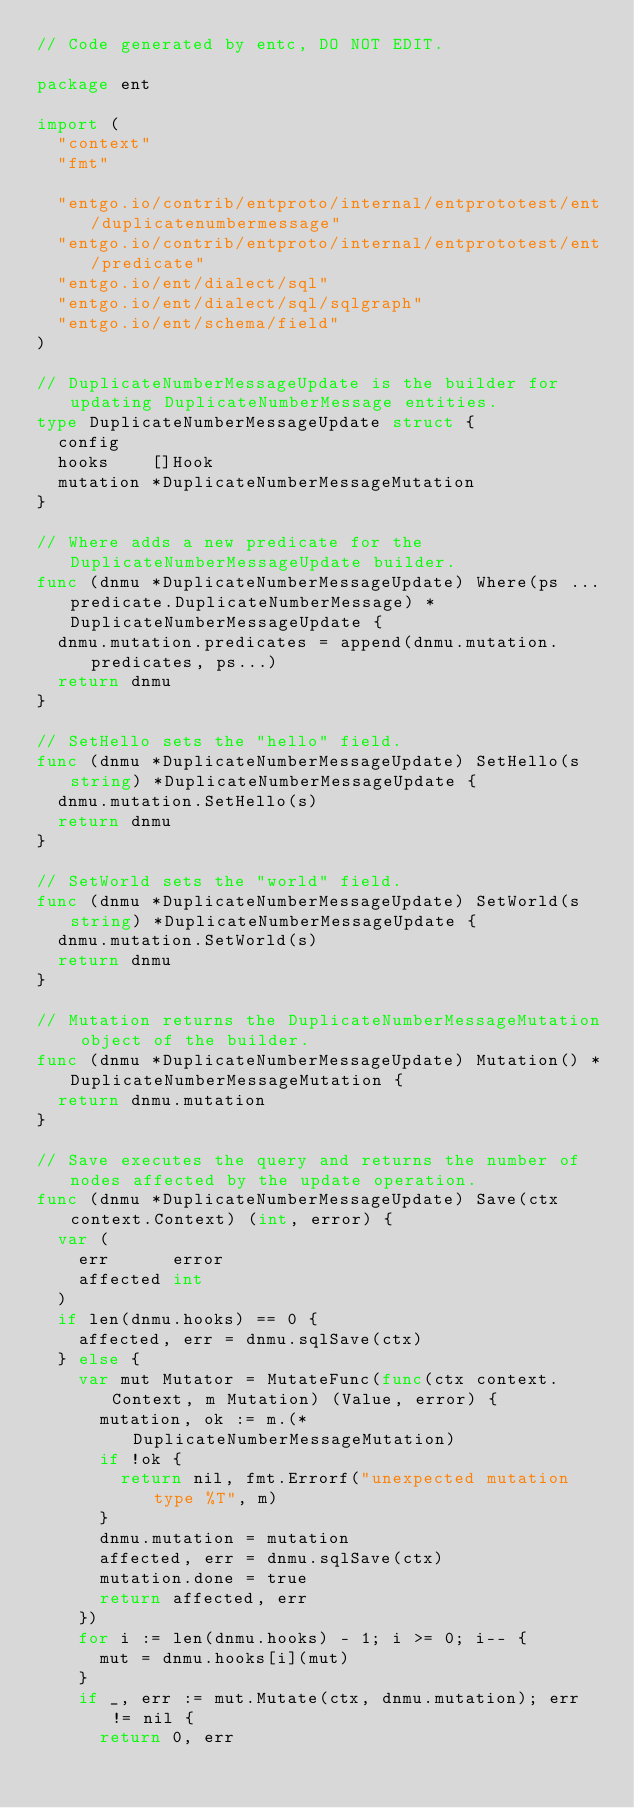<code> <loc_0><loc_0><loc_500><loc_500><_Go_>// Code generated by entc, DO NOT EDIT.

package ent

import (
	"context"
	"fmt"

	"entgo.io/contrib/entproto/internal/entprototest/ent/duplicatenumbermessage"
	"entgo.io/contrib/entproto/internal/entprototest/ent/predicate"
	"entgo.io/ent/dialect/sql"
	"entgo.io/ent/dialect/sql/sqlgraph"
	"entgo.io/ent/schema/field"
)

// DuplicateNumberMessageUpdate is the builder for updating DuplicateNumberMessage entities.
type DuplicateNumberMessageUpdate struct {
	config
	hooks    []Hook
	mutation *DuplicateNumberMessageMutation
}

// Where adds a new predicate for the DuplicateNumberMessageUpdate builder.
func (dnmu *DuplicateNumberMessageUpdate) Where(ps ...predicate.DuplicateNumberMessage) *DuplicateNumberMessageUpdate {
	dnmu.mutation.predicates = append(dnmu.mutation.predicates, ps...)
	return dnmu
}

// SetHello sets the "hello" field.
func (dnmu *DuplicateNumberMessageUpdate) SetHello(s string) *DuplicateNumberMessageUpdate {
	dnmu.mutation.SetHello(s)
	return dnmu
}

// SetWorld sets the "world" field.
func (dnmu *DuplicateNumberMessageUpdate) SetWorld(s string) *DuplicateNumberMessageUpdate {
	dnmu.mutation.SetWorld(s)
	return dnmu
}

// Mutation returns the DuplicateNumberMessageMutation object of the builder.
func (dnmu *DuplicateNumberMessageUpdate) Mutation() *DuplicateNumberMessageMutation {
	return dnmu.mutation
}

// Save executes the query and returns the number of nodes affected by the update operation.
func (dnmu *DuplicateNumberMessageUpdate) Save(ctx context.Context) (int, error) {
	var (
		err      error
		affected int
	)
	if len(dnmu.hooks) == 0 {
		affected, err = dnmu.sqlSave(ctx)
	} else {
		var mut Mutator = MutateFunc(func(ctx context.Context, m Mutation) (Value, error) {
			mutation, ok := m.(*DuplicateNumberMessageMutation)
			if !ok {
				return nil, fmt.Errorf("unexpected mutation type %T", m)
			}
			dnmu.mutation = mutation
			affected, err = dnmu.sqlSave(ctx)
			mutation.done = true
			return affected, err
		})
		for i := len(dnmu.hooks) - 1; i >= 0; i-- {
			mut = dnmu.hooks[i](mut)
		}
		if _, err := mut.Mutate(ctx, dnmu.mutation); err != nil {
			return 0, err</code> 